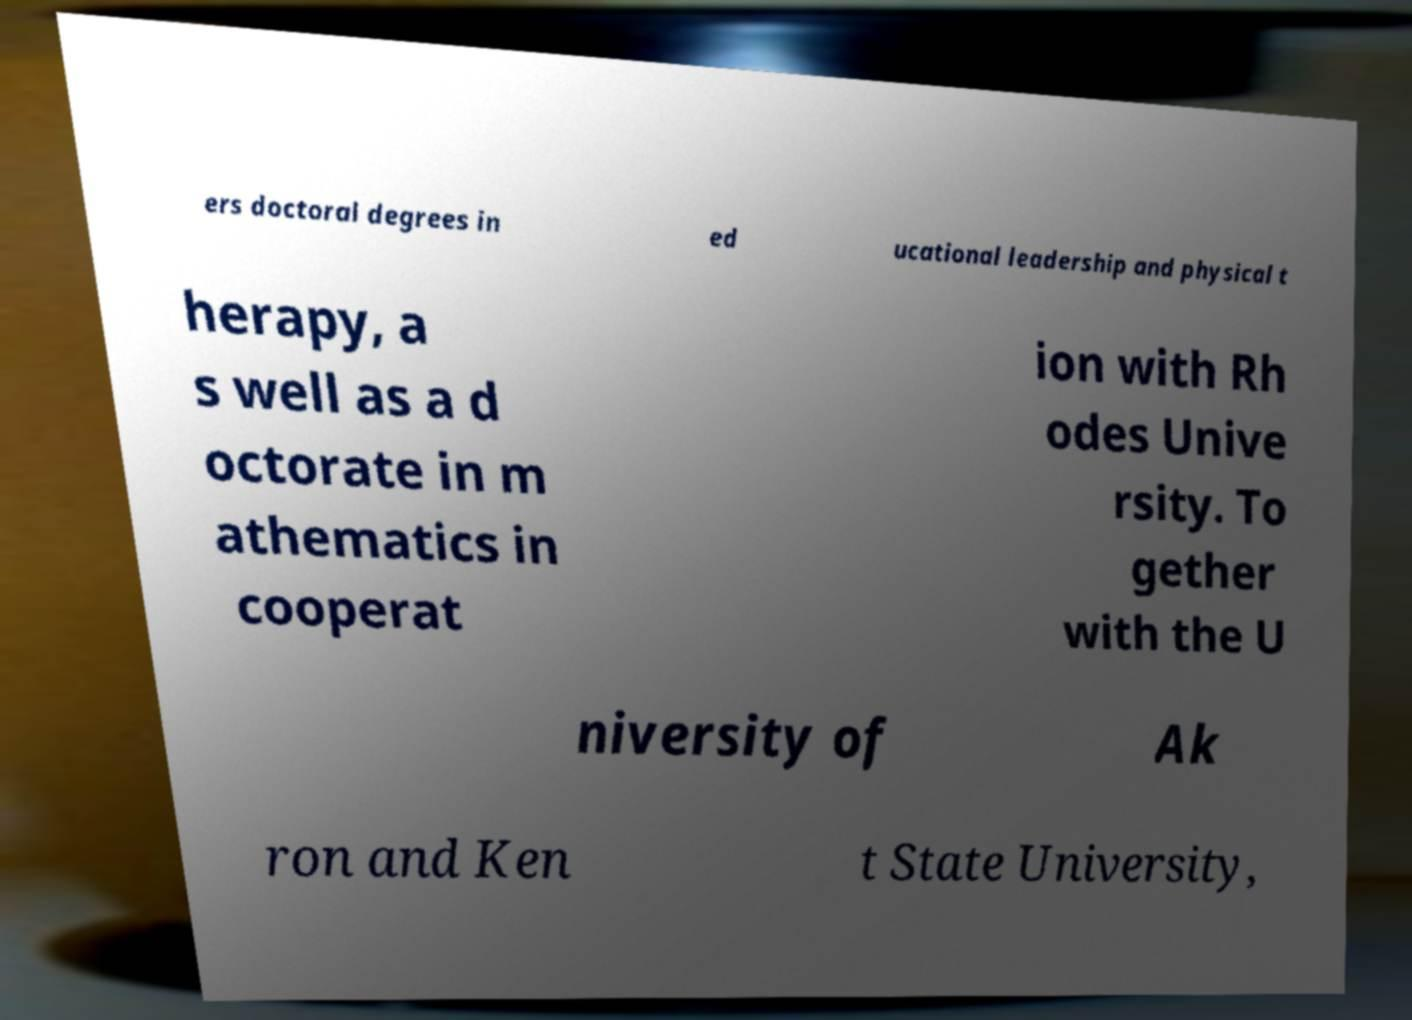There's text embedded in this image that I need extracted. Can you transcribe it verbatim? ers doctoral degrees in ed ucational leadership and physical t herapy, a s well as a d octorate in m athematics in cooperat ion with Rh odes Unive rsity. To gether with the U niversity of Ak ron and Ken t State University, 